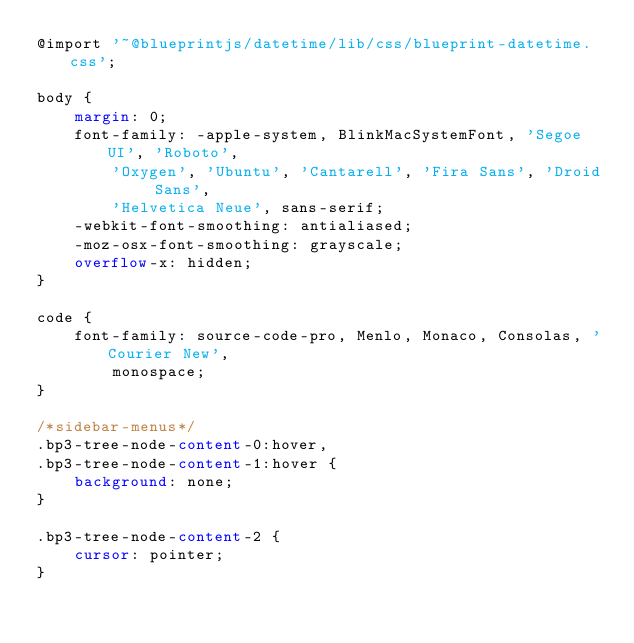Convert code to text. <code><loc_0><loc_0><loc_500><loc_500><_CSS_>@import '~@blueprintjs/datetime/lib/css/blueprint-datetime.css';

body {
    margin: 0;
    font-family: -apple-system, BlinkMacSystemFont, 'Segoe UI', 'Roboto',
        'Oxygen', 'Ubuntu', 'Cantarell', 'Fira Sans', 'Droid Sans',
        'Helvetica Neue', sans-serif;
    -webkit-font-smoothing: antialiased;
    -moz-osx-font-smoothing: grayscale;
    overflow-x: hidden;
}

code {
    font-family: source-code-pro, Menlo, Monaco, Consolas, 'Courier New',
        monospace;
}

/*sidebar-menus*/
.bp3-tree-node-content-0:hover,
.bp3-tree-node-content-1:hover {
    background: none;
}

.bp3-tree-node-content-2 {
    cursor: pointer;
}
</code> 